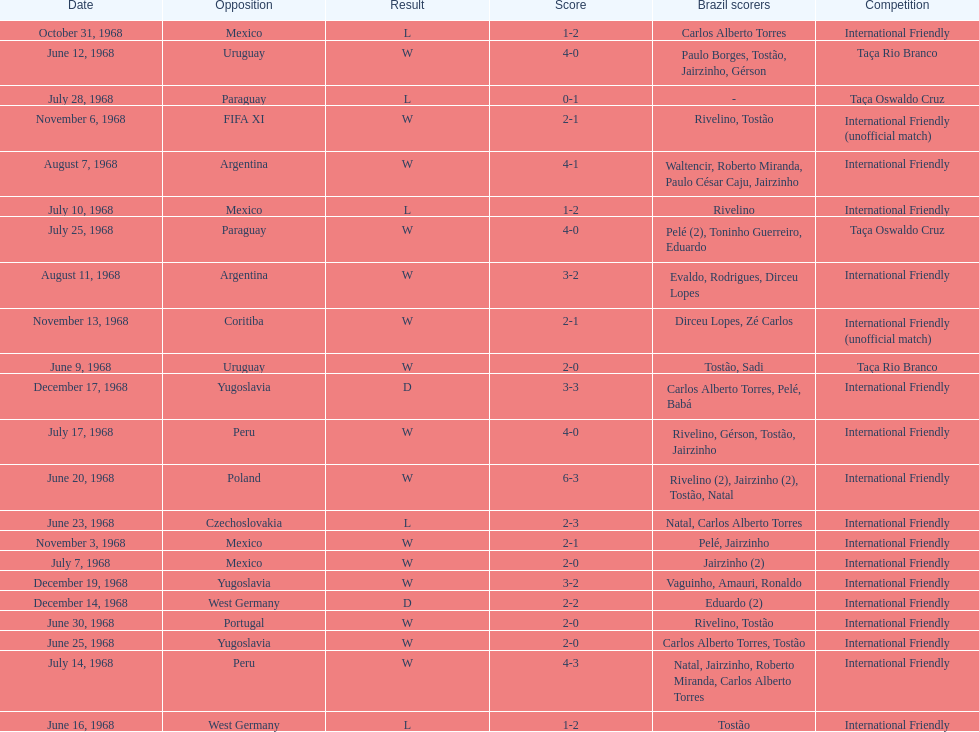What is the number of countries they have played? 11. 